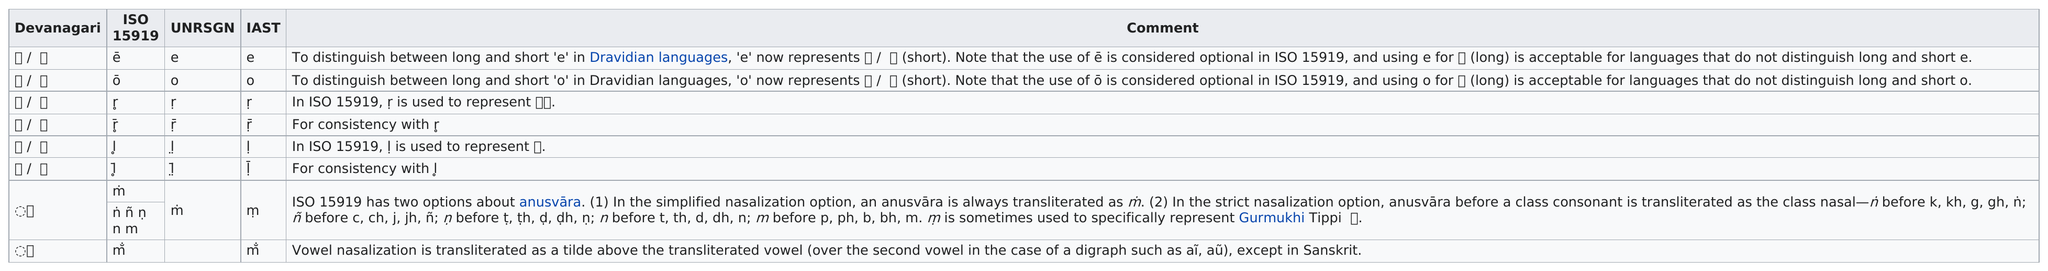Indicate a few pertinent items in this graphic. What is listed prior to the letter 'o' is called 'unrsgn'. The total number of translations is 8. There are a total of 2 options available for anusvara. The Devanagari letter "ओ" (o) is equivalent to the International Alphabet of Sanskrit Transliteration (IAST) letter "o". The Devanagari transliteration listed at the top of the table is ए / े. 